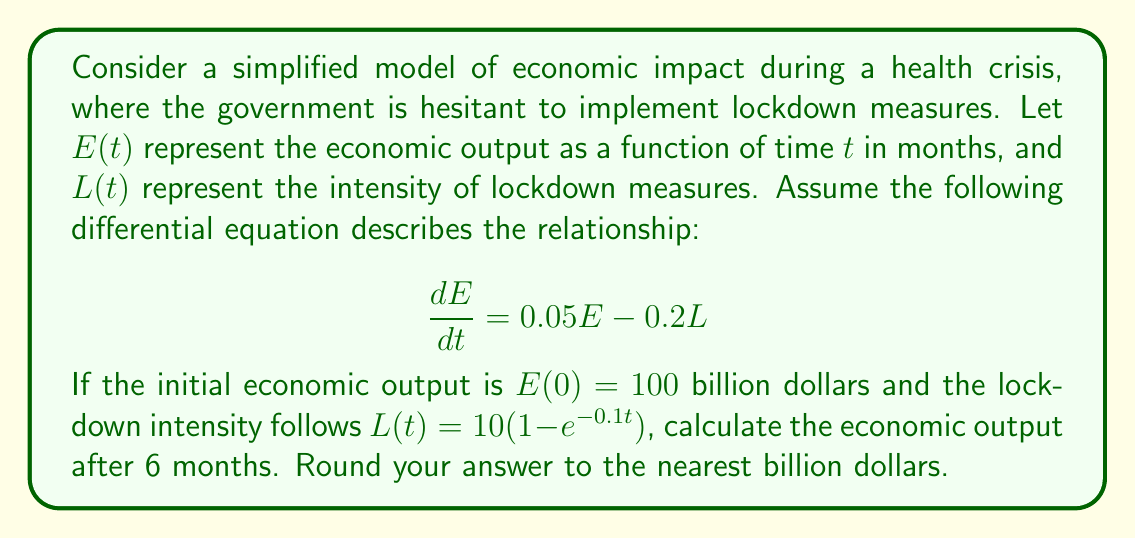Teach me how to tackle this problem. To solve this problem, we need to follow these steps:

1) First, we have a first-order linear differential equation:

   $$\frac{dE}{dt} = 0.05E - 0.2L$$

2) We're given that $L(t) = 10(1-e^{-0.1t})$. Let's substitute this into our equation:

   $$\frac{dE}{dt} = 0.05E - 0.2(10(1-e^{-0.1t}))$$
   $$\frac{dE}{dt} = 0.05E - 2 + 2e^{-0.1t}$$

3) This is now in the form of a non-homogeneous linear differential equation:

   $$\frac{dE}{dt} + (-0.05)E = -2 + 2e^{-0.1t}$$

4) The general solution to this equation is the sum of the complementary function (solution to the homogeneous equation) and a particular integral.

5) The complementary function is $E_c = Ae^{0.05t}$, where $A$ is a constant.

6) For the particular integral, we can guess a solution of the form:

   $$E_p = B + Ce^{-0.1t}$$

   where $B$ and $C$ are constants to be determined.

7) Substituting this into the original equation:

   $$-0.1Ce^{-0.1t} + (-0.05)(B + Ce^{-0.1t}) = -2 + 2e^{-0.1t}$$

8) Equating coefficients:

   For constant terms: $-0.05B = -2$, so $B = 40$
   For $e^{-0.1t}$ terms: $-0.1C - 0.05C = 2$, so $C = -13.33$

9) Therefore, the general solution is:

   $$E = Ae^{0.05t} + 40 - 13.33e^{-0.1t}$$

10) Using the initial condition $E(0) = 100$:

    $$100 = A + 40 - 13.33$$
    $$A = 73.33$$

11) So our final solution is:

    $$E(t) = 73.33e^{0.05t} + 40 - 13.33e^{-0.1t}$$

12) To find $E(6)$, we substitute $t=6$:

    $$E(6) = 73.33e^{0.3} + 40 - 13.33e^{-0.6}$$

13) Calculating this:

    $$E(6) \approx 141.37$$

14) Rounding to the nearest billion:

    $$E(6) \approx 141$$ billion dollars
Answer: 141 billion dollars 